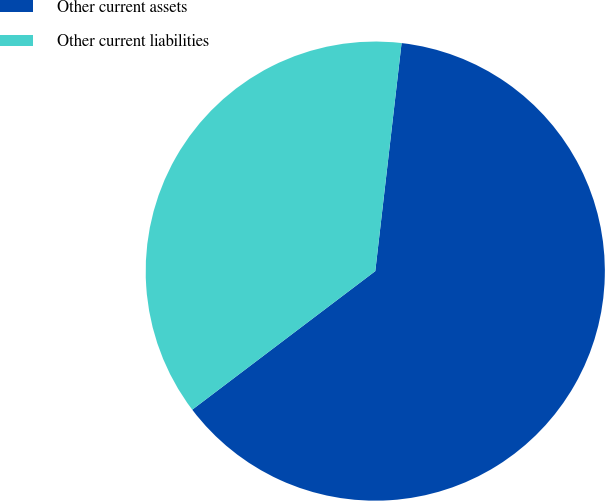Convert chart to OTSL. <chart><loc_0><loc_0><loc_500><loc_500><pie_chart><fcel>Other current assets<fcel>Other current liabilities<nl><fcel>62.86%<fcel>37.14%<nl></chart> 